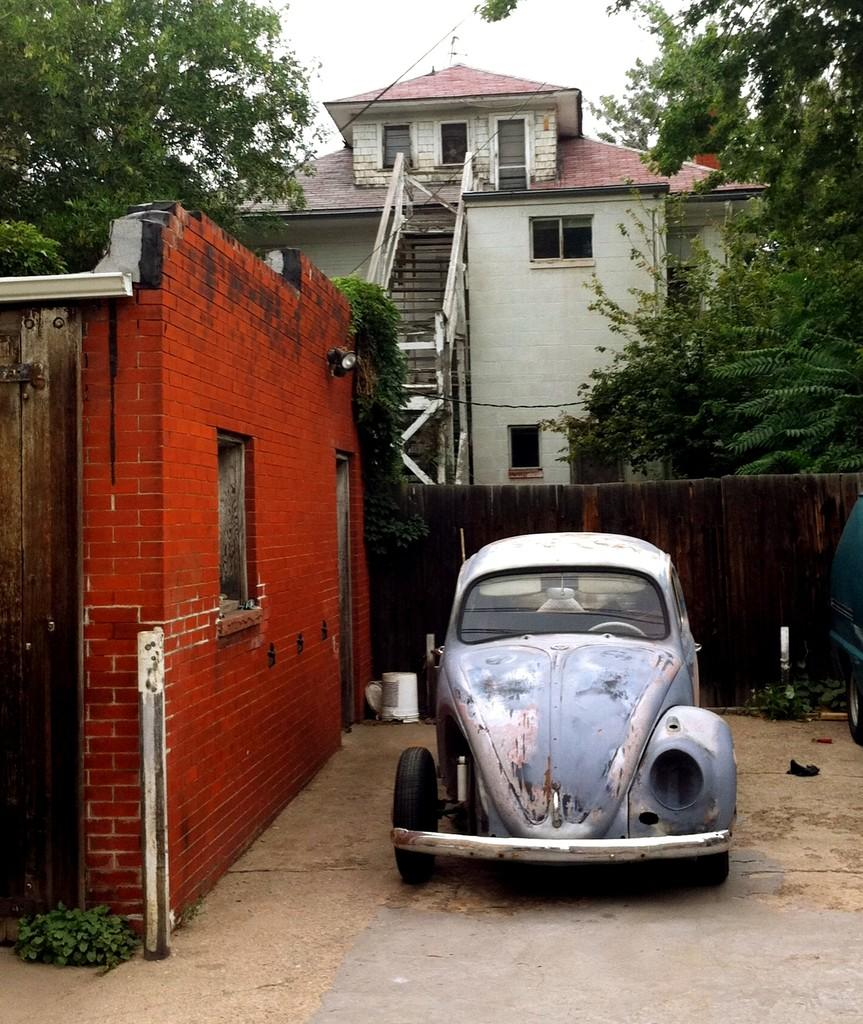What type of structures can be seen in the image? There are houses in the image. What architectural feature is present in the image? There are steps in the image. What type of vegetation is visible in the image? There are trees and plants in the image. What mode of transportation can be seen in the image? There are vehicles in the image. What is visible in the sky in the image? The sky is visible in the image. What type of barrier is present in the image? There is a fence in the image. Can you describe any unspecified objects in the image? There are unspecified objects in the image, but their details are not provided. What scent can be detected from the image? There is no information about the scent in the image, as it is a visual medium. What type of wall is present in the image? There is no mention of a wall in the provided facts, so it cannot be determined from the image. 